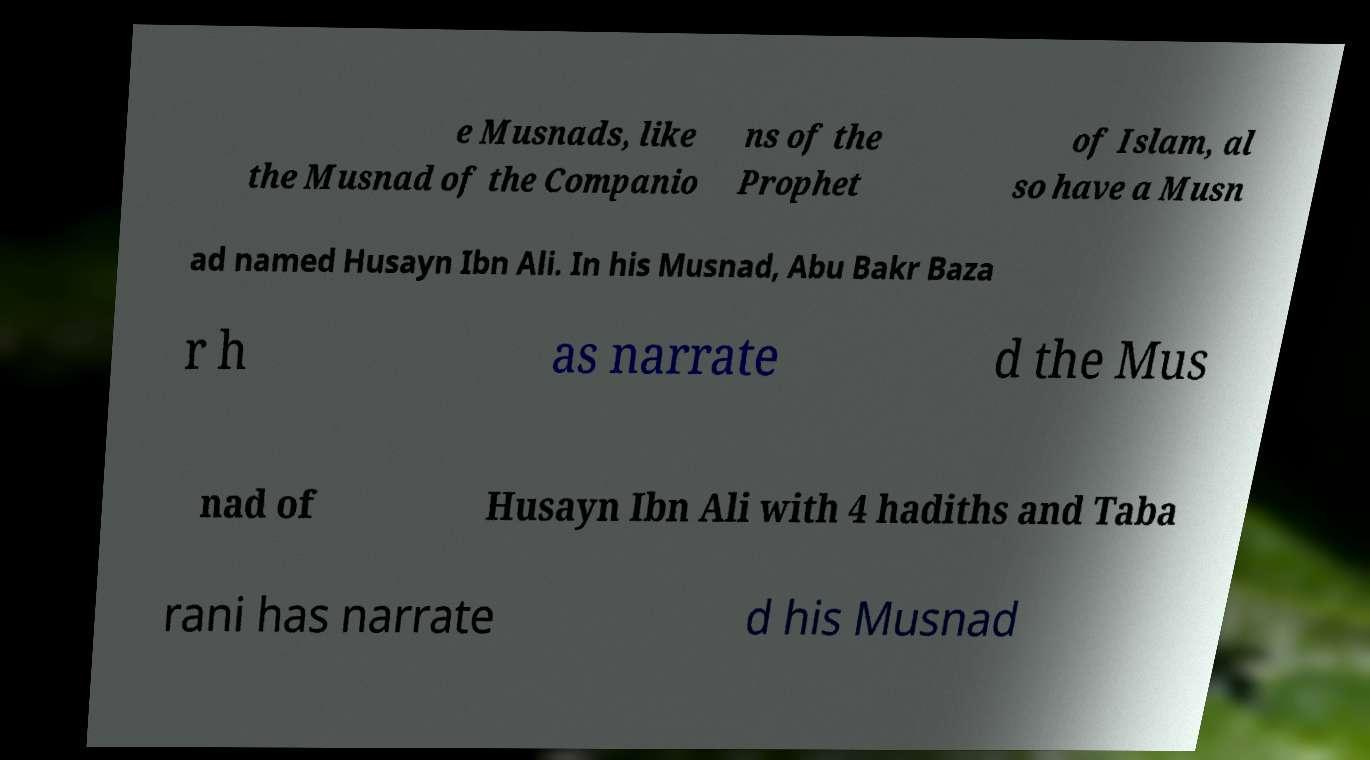For documentation purposes, I need the text within this image transcribed. Could you provide that? e Musnads, like the Musnad of the Companio ns of the Prophet of Islam, al so have a Musn ad named Husayn Ibn Ali. In his Musnad, Abu Bakr Baza r h as narrate d the Mus nad of Husayn Ibn Ali with 4 hadiths and Taba rani has narrate d his Musnad 